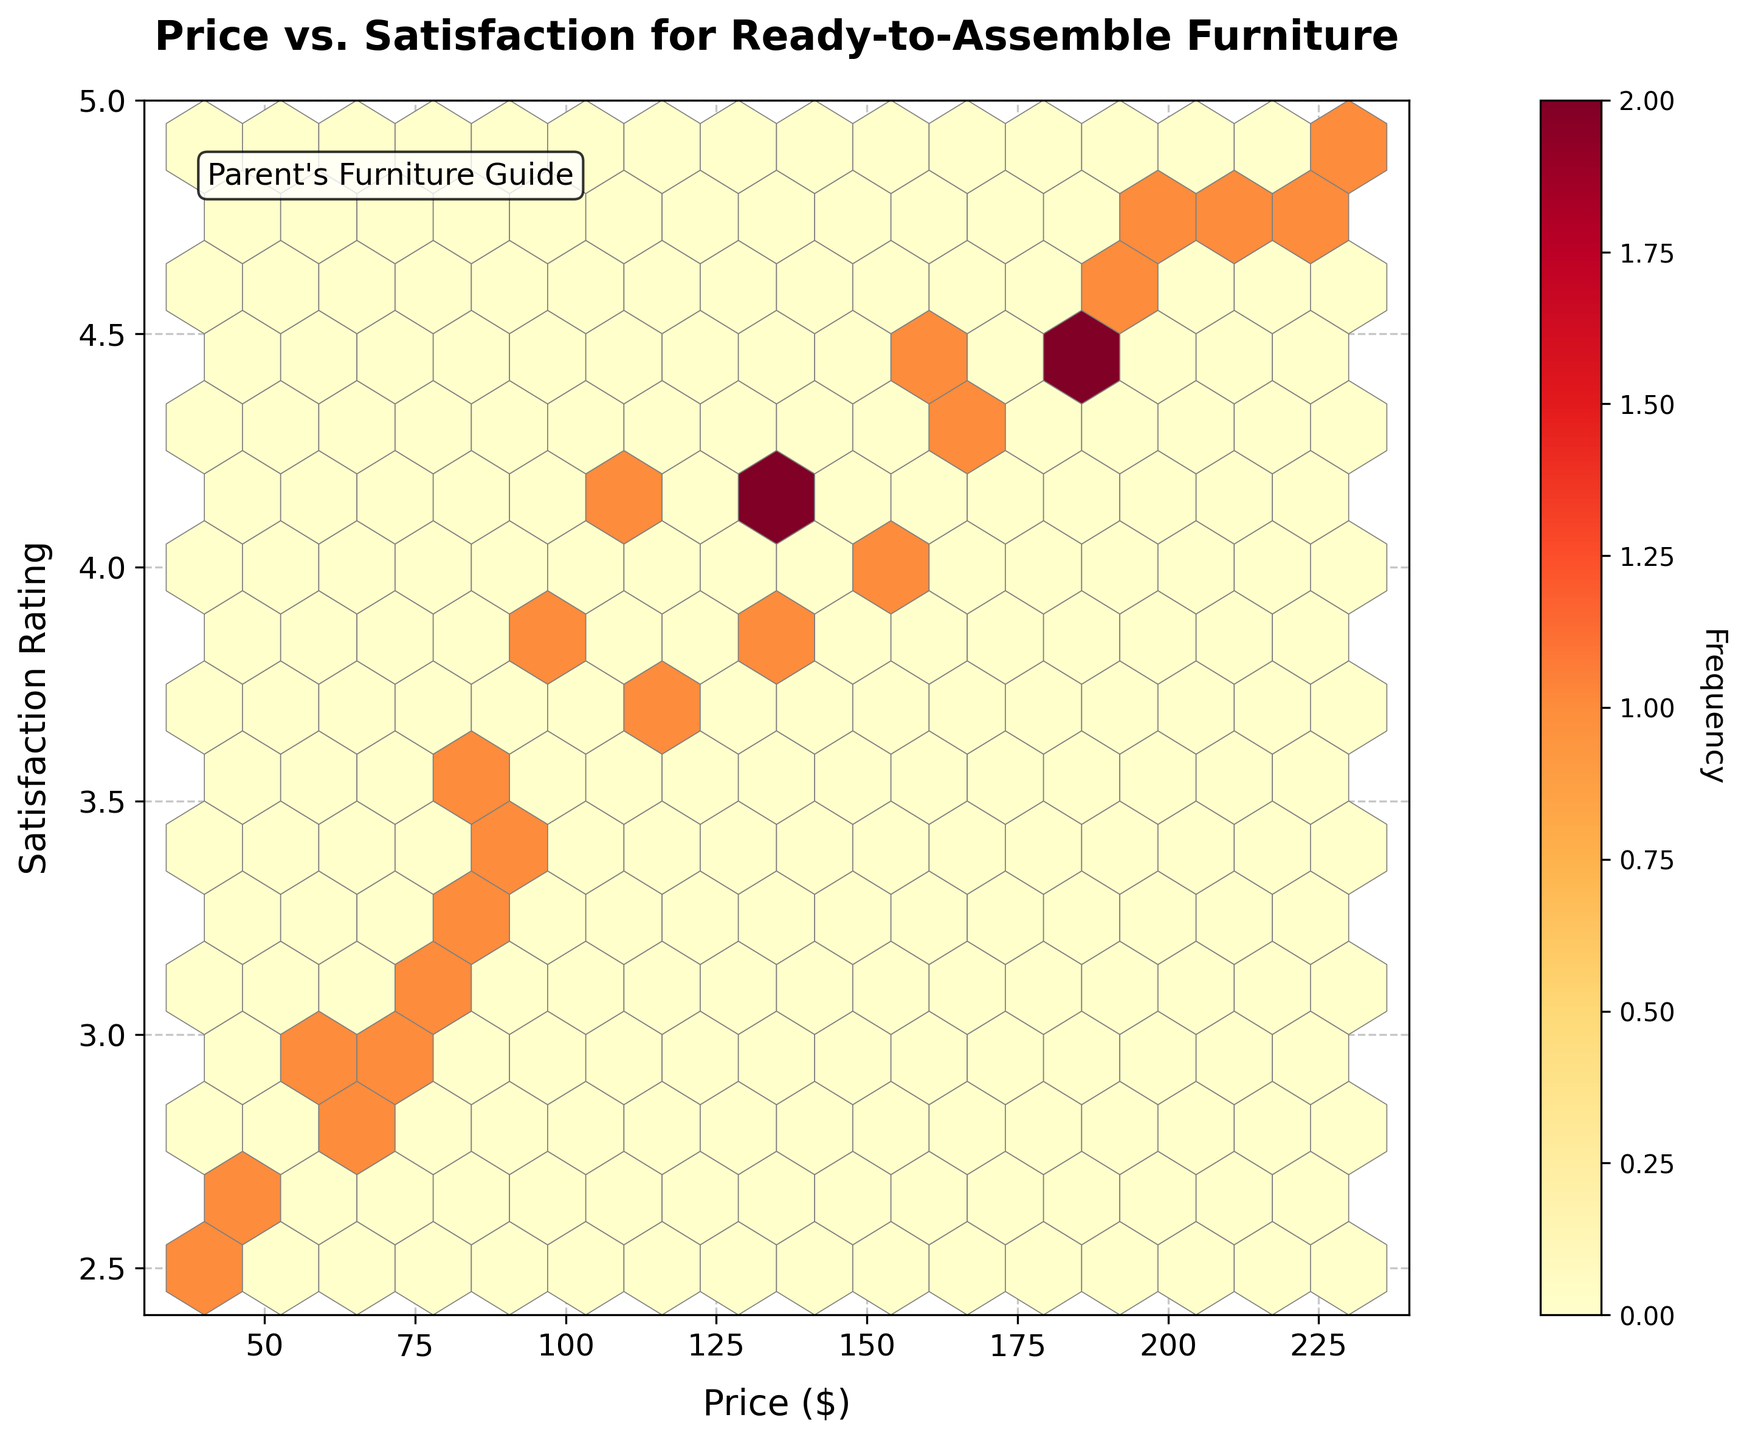What's the title of the plot? The title is given at the top of the plot.
Answer: Price vs. Satisfaction for Ready-to-Assemble Furniture What are the labels of the x and y axes? The labels are near the respective axes. The x-axis label is "Price ($)" and the y-axis label is "Satisfaction Rating."
Answer: Price ($) and Satisfaction Rating What color is the most frequent hexbin? The color indicates the frequency and the color scale is shown via the color bar. The most frequent hexbin is red as indicated in the color bar.
Answer: Red What is the general trend between price and customer satisfaction? The general trend can be observed by looking at the concentration pattern in the hexbin plot. Higher satisfaction ratings are generally found with higher prices.
Answer: Satisfaction increases with price Are there more data points with prices below $100 or above $100? By observing the density of hexbins around the price ranges of $100, you can see there are more data points above $100 as more hexbins are colored higher up on the frequency scale above the $100 mark.
Answer: Above $100 What price range has the highest customer satisfaction rating? The satisfaction rating is highest around 4.7 to 4.9, and these hexbins are found in the price range of approximately $200 to $230.
Answer: $200 to $230 Do lower-priced furniture items (below $100) show a lower satisfaction rating compared to higher-priced items (above $100)? By comparing the density and color of hexbins below $100 and above $100, it's evident that lower-priced items generally have lower satisfaction ratings with more occurrences in the range of 2.8 to 3.5, whereas higher-priced items have higher satisfaction ratings.
Answer: Yes, lower satisfaction What is the frequency label shown on the color bar? The color bar next to the plot shows the label "Frequency," which indicates how many data points fall into each hexbin.
Answer: Frequency Is there a price range where satisfaction varies more widely? The variation of satisfaction can be observed by looking at the spread of satisfaction ratings for specific price ranges. Prices around $100 to $150 show a wider spread in satisfaction ratings, ranging from about 3.3 to 4.2.
Answer: $100 to $150 At approximately which price and satisfaction rating does the highest hexbin occur? The highest hexbin can be identified by finding the most saturated (red) hexbin on the plot, which is around $200 and a satisfaction rating of about 4.8.
Answer: $200 and 4.8 